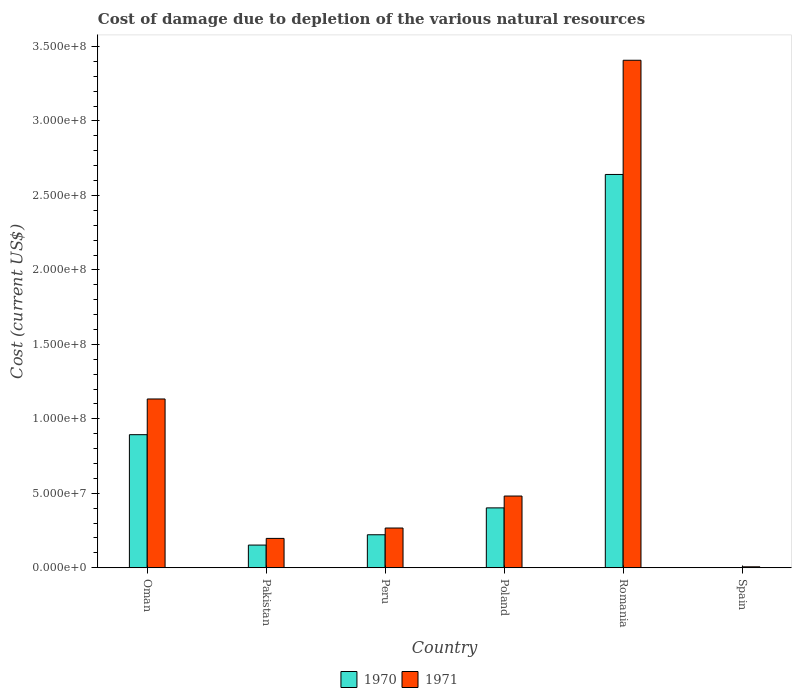How many different coloured bars are there?
Give a very brief answer. 2. How many bars are there on the 3rd tick from the left?
Your answer should be compact. 2. In how many cases, is the number of bars for a given country not equal to the number of legend labels?
Keep it short and to the point. 0. What is the cost of damage caused due to the depletion of various natural resources in 1970 in Poland?
Offer a terse response. 4.02e+07. Across all countries, what is the maximum cost of damage caused due to the depletion of various natural resources in 1970?
Ensure brevity in your answer.  2.64e+08. Across all countries, what is the minimum cost of damage caused due to the depletion of various natural resources in 1970?
Offer a terse response. 1.78e+04. In which country was the cost of damage caused due to the depletion of various natural resources in 1970 maximum?
Ensure brevity in your answer.  Romania. In which country was the cost of damage caused due to the depletion of various natural resources in 1970 minimum?
Give a very brief answer. Spain. What is the total cost of damage caused due to the depletion of various natural resources in 1971 in the graph?
Provide a short and direct response. 5.49e+08. What is the difference between the cost of damage caused due to the depletion of various natural resources in 1970 in Peru and that in Poland?
Keep it short and to the point. -1.80e+07. What is the difference between the cost of damage caused due to the depletion of various natural resources in 1971 in Poland and the cost of damage caused due to the depletion of various natural resources in 1970 in Spain?
Your answer should be compact. 4.81e+07. What is the average cost of damage caused due to the depletion of various natural resources in 1971 per country?
Provide a succinct answer. 9.15e+07. What is the difference between the cost of damage caused due to the depletion of various natural resources of/in 1971 and cost of damage caused due to the depletion of various natural resources of/in 1970 in Spain?
Give a very brief answer. 6.07e+05. In how many countries, is the cost of damage caused due to the depletion of various natural resources in 1970 greater than 330000000 US$?
Your answer should be very brief. 0. What is the ratio of the cost of damage caused due to the depletion of various natural resources in 1971 in Pakistan to that in Spain?
Offer a very short reply. 31.53. Is the difference between the cost of damage caused due to the depletion of various natural resources in 1971 in Poland and Romania greater than the difference between the cost of damage caused due to the depletion of various natural resources in 1970 in Poland and Romania?
Your response must be concise. No. What is the difference between the highest and the second highest cost of damage caused due to the depletion of various natural resources in 1970?
Offer a terse response. 1.75e+08. What is the difference between the highest and the lowest cost of damage caused due to the depletion of various natural resources in 1971?
Provide a succinct answer. 3.40e+08. Is the sum of the cost of damage caused due to the depletion of various natural resources in 1970 in Oman and Romania greater than the maximum cost of damage caused due to the depletion of various natural resources in 1971 across all countries?
Offer a very short reply. Yes. What does the 1st bar from the left in Spain represents?
Your response must be concise. 1970. What does the 2nd bar from the right in Peru represents?
Ensure brevity in your answer.  1970. How many bars are there?
Your response must be concise. 12. Are all the bars in the graph horizontal?
Provide a short and direct response. No. Are the values on the major ticks of Y-axis written in scientific E-notation?
Provide a short and direct response. Yes. Does the graph contain grids?
Offer a terse response. No. What is the title of the graph?
Your answer should be compact. Cost of damage due to depletion of the various natural resources. What is the label or title of the X-axis?
Provide a succinct answer. Country. What is the label or title of the Y-axis?
Your answer should be compact. Cost (current US$). What is the Cost (current US$) in 1970 in Oman?
Your answer should be compact. 8.94e+07. What is the Cost (current US$) of 1971 in Oman?
Give a very brief answer. 1.13e+08. What is the Cost (current US$) of 1970 in Pakistan?
Offer a terse response. 1.52e+07. What is the Cost (current US$) of 1971 in Pakistan?
Offer a very short reply. 1.97e+07. What is the Cost (current US$) of 1970 in Peru?
Keep it short and to the point. 2.22e+07. What is the Cost (current US$) of 1971 in Peru?
Make the answer very short. 2.67e+07. What is the Cost (current US$) in 1970 in Poland?
Keep it short and to the point. 4.02e+07. What is the Cost (current US$) of 1971 in Poland?
Offer a terse response. 4.82e+07. What is the Cost (current US$) of 1970 in Romania?
Provide a short and direct response. 2.64e+08. What is the Cost (current US$) of 1971 in Romania?
Provide a succinct answer. 3.41e+08. What is the Cost (current US$) of 1970 in Spain?
Offer a terse response. 1.78e+04. What is the Cost (current US$) of 1971 in Spain?
Offer a very short reply. 6.25e+05. Across all countries, what is the maximum Cost (current US$) in 1970?
Offer a very short reply. 2.64e+08. Across all countries, what is the maximum Cost (current US$) in 1971?
Offer a very short reply. 3.41e+08. Across all countries, what is the minimum Cost (current US$) in 1970?
Ensure brevity in your answer.  1.78e+04. Across all countries, what is the minimum Cost (current US$) in 1971?
Make the answer very short. 6.25e+05. What is the total Cost (current US$) of 1970 in the graph?
Your answer should be very brief. 4.31e+08. What is the total Cost (current US$) in 1971 in the graph?
Your response must be concise. 5.49e+08. What is the difference between the Cost (current US$) of 1970 in Oman and that in Pakistan?
Provide a short and direct response. 7.41e+07. What is the difference between the Cost (current US$) in 1971 in Oman and that in Pakistan?
Your response must be concise. 9.36e+07. What is the difference between the Cost (current US$) in 1970 in Oman and that in Peru?
Make the answer very short. 6.72e+07. What is the difference between the Cost (current US$) of 1971 in Oman and that in Peru?
Your answer should be compact. 8.66e+07. What is the difference between the Cost (current US$) in 1970 in Oman and that in Poland?
Offer a terse response. 4.92e+07. What is the difference between the Cost (current US$) in 1971 in Oman and that in Poland?
Ensure brevity in your answer.  6.52e+07. What is the difference between the Cost (current US$) of 1970 in Oman and that in Romania?
Provide a short and direct response. -1.75e+08. What is the difference between the Cost (current US$) in 1971 in Oman and that in Romania?
Provide a succinct answer. -2.27e+08. What is the difference between the Cost (current US$) of 1970 in Oman and that in Spain?
Your answer should be compact. 8.93e+07. What is the difference between the Cost (current US$) in 1971 in Oman and that in Spain?
Offer a very short reply. 1.13e+08. What is the difference between the Cost (current US$) in 1970 in Pakistan and that in Peru?
Your answer should be very brief. -6.92e+06. What is the difference between the Cost (current US$) in 1971 in Pakistan and that in Peru?
Ensure brevity in your answer.  -6.98e+06. What is the difference between the Cost (current US$) of 1970 in Pakistan and that in Poland?
Your answer should be compact. -2.50e+07. What is the difference between the Cost (current US$) in 1971 in Pakistan and that in Poland?
Ensure brevity in your answer.  -2.84e+07. What is the difference between the Cost (current US$) of 1970 in Pakistan and that in Romania?
Provide a succinct answer. -2.49e+08. What is the difference between the Cost (current US$) of 1971 in Pakistan and that in Romania?
Your answer should be very brief. -3.21e+08. What is the difference between the Cost (current US$) of 1970 in Pakistan and that in Spain?
Ensure brevity in your answer.  1.52e+07. What is the difference between the Cost (current US$) in 1971 in Pakistan and that in Spain?
Your answer should be very brief. 1.91e+07. What is the difference between the Cost (current US$) in 1970 in Peru and that in Poland?
Keep it short and to the point. -1.80e+07. What is the difference between the Cost (current US$) of 1971 in Peru and that in Poland?
Keep it short and to the point. -2.15e+07. What is the difference between the Cost (current US$) of 1970 in Peru and that in Romania?
Offer a very short reply. -2.42e+08. What is the difference between the Cost (current US$) in 1971 in Peru and that in Romania?
Offer a terse response. -3.14e+08. What is the difference between the Cost (current US$) in 1970 in Peru and that in Spain?
Ensure brevity in your answer.  2.21e+07. What is the difference between the Cost (current US$) in 1971 in Peru and that in Spain?
Your response must be concise. 2.61e+07. What is the difference between the Cost (current US$) in 1970 in Poland and that in Romania?
Provide a short and direct response. -2.24e+08. What is the difference between the Cost (current US$) in 1971 in Poland and that in Romania?
Your answer should be compact. -2.93e+08. What is the difference between the Cost (current US$) in 1970 in Poland and that in Spain?
Give a very brief answer. 4.02e+07. What is the difference between the Cost (current US$) in 1971 in Poland and that in Spain?
Keep it short and to the point. 4.75e+07. What is the difference between the Cost (current US$) of 1970 in Romania and that in Spain?
Your answer should be very brief. 2.64e+08. What is the difference between the Cost (current US$) in 1971 in Romania and that in Spain?
Give a very brief answer. 3.40e+08. What is the difference between the Cost (current US$) in 1970 in Oman and the Cost (current US$) in 1971 in Pakistan?
Give a very brief answer. 6.96e+07. What is the difference between the Cost (current US$) of 1970 in Oman and the Cost (current US$) of 1971 in Peru?
Provide a succinct answer. 6.27e+07. What is the difference between the Cost (current US$) of 1970 in Oman and the Cost (current US$) of 1971 in Poland?
Offer a very short reply. 4.12e+07. What is the difference between the Cost (current US$) of 1970 in Oman and the Cost (current US$) of 1971 in Romania?
Your answer should be compact. -2.51e+08. What is the difference between the Cost (current US$) in 1970 in Oman and the Cost (current US$) in 1971 in Spain?
Keep it short and to the point. 8.87e+07. What is the difference between the Cost (current US$) of 1970 in Pakistan and the Cost (current US$) of 1971 in Peru?
Ensure brevity in your answer.  -1.15e+07. What is the difference between the Cost (current US$) in 1970 in Pakistan and the Cost (current US$) in 1971 in Poland?
Keep it short and to the point. -3.29e+07. What is the difference between the Cost (current US$) in 1970 in Pakistan and the Cost (current US$) in 1971 in Romania?
Your answer should be compact. -3.26e+08. What is the difference between the Cost (current US$) in 1970 in Pakistan and the Cost (current US$) in 1971 in Spain?
Provide a succinct answer. 1.46e+07. What is the difference between the Cost (current US$) of 1970 in Peru and the Cost (current US$) of 1971 in Poland?
Keep it short and to the point. -2.60e+07. What is the difference between the Cost (current US$) of 1970 in Peru and the Cost (current US$) of 1971 in Romania?
Provide a succinct answer. -3.19e+08. What is the difference between the Cost (current US$) of 1970 in Peru and the Cost (current US$) of 1971 in Spain?
Your response must be concise. 2.15e+07. What is the difference between the Cost (current US$) of 1970 in Poland and the Cost (current US$) of 1971 in Romania?
Make the answer very short. -3.01e+08. What is the difference between the Cost (current US$) of 1970 in Poland and the Cost (current US$) of 1971 in Spain?
Provide a succinct answer. 3.96e+07. What is the difference between the Cost (current US$) of 1970 in Romania and the Cost (current US$) of 1971 in Spain?
Provide a short and direct response. 2.63e+08. What is the average Cost (current US$) of 1970 per country?
Provide a short and direct response. 7.18e+07. What is the average Cost (current US$) of 1971 per country?
Your answer should be very brief. 9.15e+07. What is the difference between the Cost (current US$) of 1970 and Cost (current US$) of 1971 in Oman?
Your answer should be compact. -2.40e+07. What is the difference between the Cost (current US$) of 1970 and Cost (current US$) of 1971 in Pakistan?
Your response must be concise. -4.48e+06. What is the difference between the Cost (current US$) of 1970 and Cost (current US$) of 1971 in Peru?
Your response must be concise. -4.53e+06. What is the difference between the Cost (current US$) in 1970 and Cost (current US$) in 1971 in Poland?
Offer a terse response. -7.95e+06. What is the difference between the Cost (current US$) of 1970 and Cost (current US$) of 1971 in Romania?
Offer a very short reply. -7.67e+07. What is the difference between the Cost (current US$) of 1970 and Cost (current US$) of 1971 in Spain?
Make the answer very short. -6.07e+05. What is the ratio of the Cost (current US$) in 1970 in Oman to that in Pakistan?
Provide a short and direct response. 5.87. What is the ratio of the Cost (current US$) of 1971 in Oman to that in Pakistan?
Your response must be concise. 5.75. What is the ratio of the Cost (current US$) in 1970 in Oman to that in Peru?
Offer a very short reply. 4.03. What is the ratio of the Cost (current US$) in 1971 in Oman to that in Peru?
Offer a terse response. 4.25. What is the ratio of the Cost (current US$) in 1970 in Oman to that in Poland?
Provide a short and direct response. 2.22. What is the ratio of the Cost (current US$) in 1971 in Oman to that in Poland?
Offer a terse response. 2.35. What is the ratio of the Cost (current US$) of 1970 in Oman to that in Romania?
Ensure brevity in your answer.  0.34. What is the ratio of the Cost (current US$) in 1971 in Oman to that in Romania?
Your response must be concise. 0.33. What is the ratio of the Cost (current US$) of 1970 in Oman to that in Spain?
Provide a succinct answer. 5022.2. What is the ratio of the Cost (current US$) in 1971 in Oman to that in Spain?
Ensure brevity in your answer.  181.33. What is the ratio of the Cost (current US$) in 1970 in Pakistan to that in Peru?
Your answer should be very brief. 0.69. What is the ratio of the Cost (current US$) in 1971 in Pakistan to that in Peru?
Offer a terse response. 0.74. What is the ratio of the Cost (current US$) of 1970 in Pakistan to that in Poland?
Your response must be concise. 0.38. What is the ratio of the Cost (current US$) in 1971 in Pakistan to that in Poland?
Your answer should be very brief. 0.41. What is the ratio of the Cost (current US$) of 1970 in Pakistan to that in Romania?
Keep it short and to the point. 0.06. What is the ratio of the Cost (current US$) of 1971 in Pakistan to that in Romania?
Provide a succinct answer. 0.06. What is the ratio of the Cost (current US$) in 1970 in Pakistan to that in Spain?
Give a very brief answer. 856.12. What is the ratio of the Cost (current US$) in 1971 in Pakistan to that in Spain?
Offer a very short reply. 31.53. What is the ratio of the Cost (current US$) in 1970 in Peru to that in Poland?
Give a very brief answer. 0.55. What is the ratio of the Cost (current US$) of 1971 in Peru to that in Poland?
Your answer should be very brief. 0.55. What is the ratio of the Cost (current US$) of 1970 in Peru to that in Romania?
Ensure brevity in your answer.  0.08. What is the ratio of the Cost (current US$) of 1971 in Peru to that in Romania?
Make the answer very short. 0.08. What is the ratio of the Cost (current US$) of 1970 in Peru to that in Spain?
Make the answer very short. 1245.27. What is the ratio of the Cost (current US$) of 1971 in Peru to that in Spain?
Ensure brevity in your answer.  42.69. What is the ratio of the Cost (current US$) in 1970 in Poland to that in Romania?
Your response must be concise. 0.15. What is the ratio of the Cost (current US$) in 1971 in Poland to that in Romania?
Offer a terse response. 0.14. What is the ratio of the Cost (current US$) in 1970 in Poland to that in Spain?
Offer a very short reply. 2259.53. What is the ratio of the Cost (current US$) of 1971 in Poland to that in Spain?
Offer a very short reply. 77.04. What is the ratio of the Cost (current US$) in 1970 in Romania to that in Spain?
Make the answer very short. 1.48e+04. What is the ratio of the Cost (current US$) of 1971 in Romania to that in Spain?
Offer a very short reply. 545.26. What is the difference between the highest and the second highest Cost (current US$) of 1970?
Ensure brevity in your answer.  1.75e+08. What is the difference between the highest and the second highest Cost (current US$) of 1971?
Offer a terse response. 2.27e+08. What is the difference between the highest and the lowest Cost (current US$) of 1970?
Provide a succinct answer. 2.64e+08. What is the difference between the highest and the lowest Cost (current US$) in 1971?
Provide a short and direct response. 3.40e+08. 